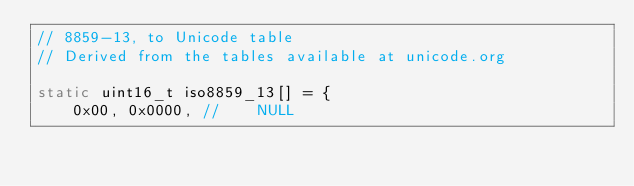Convert code to text. <code><loc_0><loc_0><loc_500><loc_500><_C_>// 8859-13, to Unicode table
// Derived from the tables available at unicode.org

static uint16_t iso8859_13[] = {
    0x00, 0x0000, //	NULL</code> 